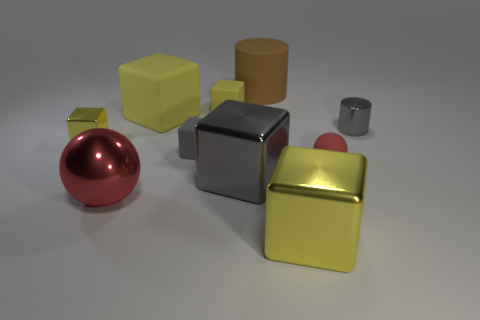What number of big rubber cylinders are on the left side of the tiny matte block that is in front of the gray object that is on the right side of the brown matte thing? 0 